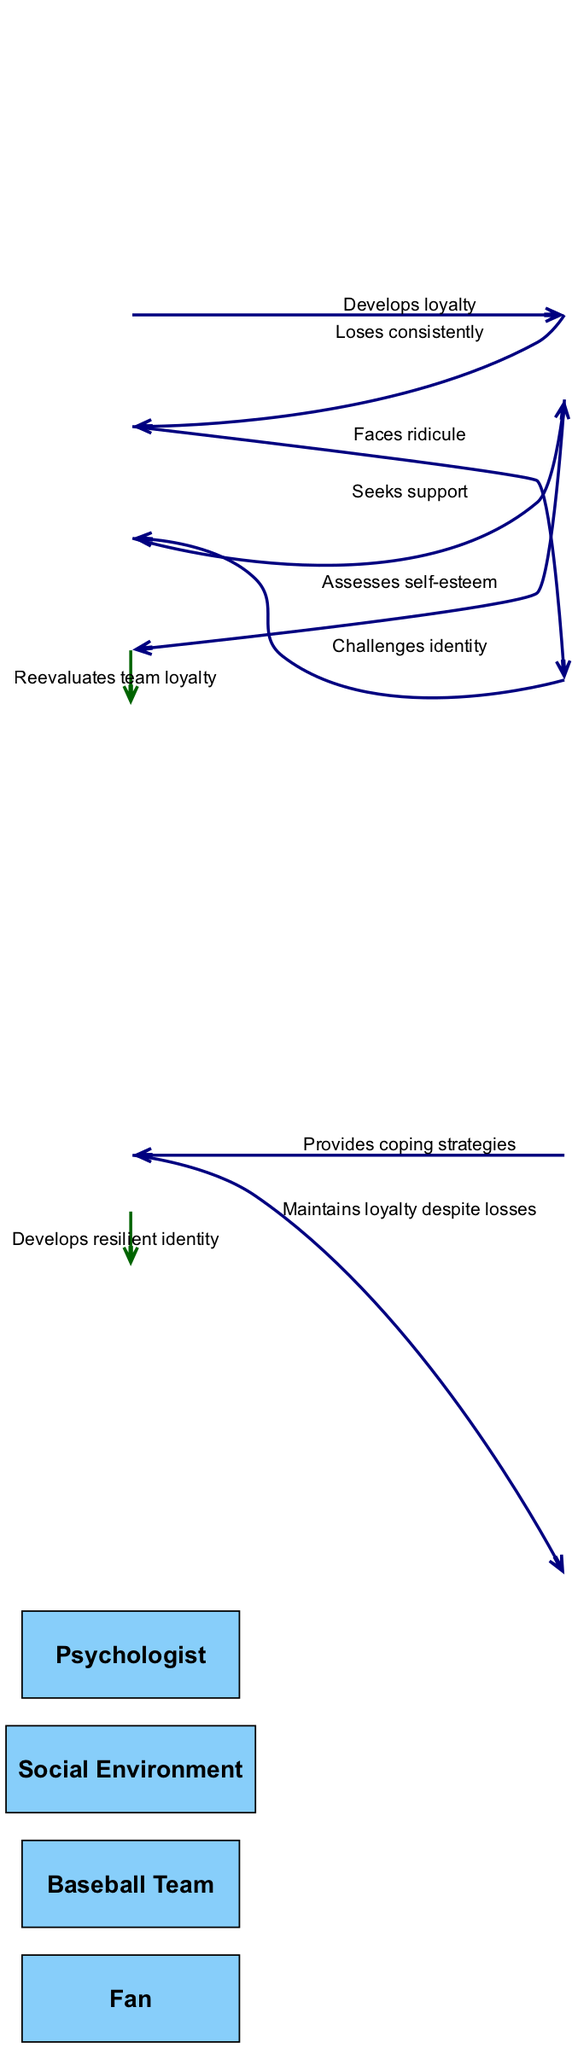What is the first action taken by the Fan in the sequence? The first action taken by the Fan is "Develops loyalty", which is the initial message sent from the Fan to the Baseball Team.
Answer: Develops loyalty How many actors are involved in this sequence diagram? The sequence diagram lists four actors: Fan, Baseball Team, Social Environment, and Psychologist.
Answer: Four What message does the Social Environment send back to the Fan? The Social Environment sends the message "Challenges identity" back to the Fan, which indicates that it responds to the ridicule the Fan faces.
Answer: Challenges identity In which step does the Fan seek support from the Psychologist? The Fan seeks support from the Psychologist in the fourth step of the sequence, represented by the message "Seeks support".
Answer: Fourth step What is the final self-message from the Fan? The final self-message from the Fan is "Develops resilient identity," indicating a positive outcome of the sequence after the various challenges faced.
Answer: Develops resilient identity What message indicates the Baseball Team's performance? The message that indicates the Baseball Team's performance is "Loses consistently," which is crucial in understanding the context of the Fan's loyalty and its effects.
Answer: Loses consistently How does the Psychologist assist the Fan? The Psychologist assists the Fan by providing "Coping strategies" as a response to the support sought by the Fan earlier in the sequence.
Answer: Coping strategies Which two actors interact directly after the Fan faces ridicule? After the Fan faces ridicule, the Social Environment interacts directly with the Fan by sending the message "Challenges identity."
Answer: Fan and Social Environment What action does the Fan take after being assessed by the Psychologist? After being assessed by the Psychologist, the Fan takes the action to "Reevaluate team loyalty," indicating a moment of introspection.
Answer: Reevaluates team loyalty 